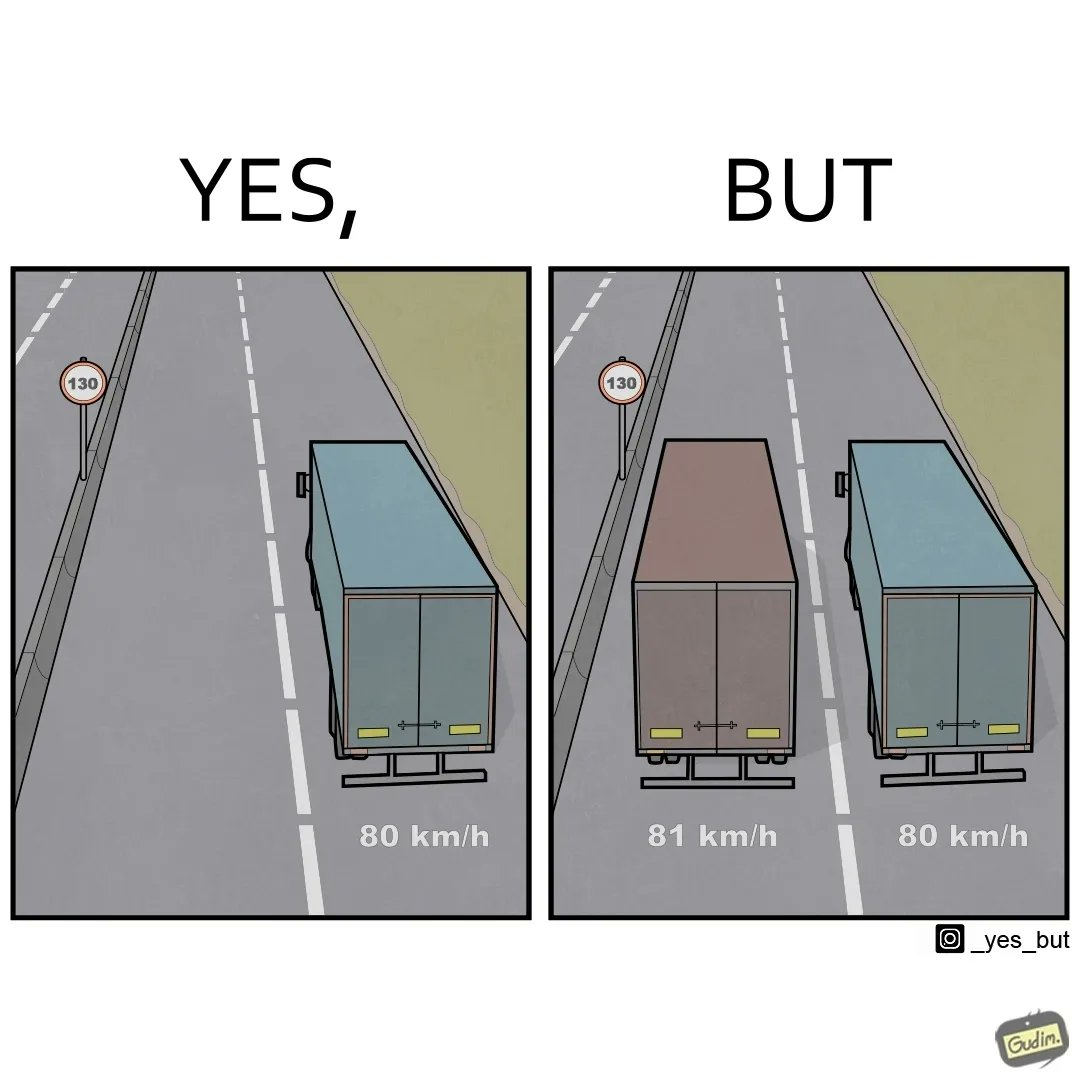Explain the humor or irony in this image. The images are funny since even though the speed limit in the zone is 130km/h, a truck travelling at 81 km/h decides to overtake another travelling 80km/h. The faster truck is barely faster and takes a long time to overtake causing other faster road users to get annoyed. 